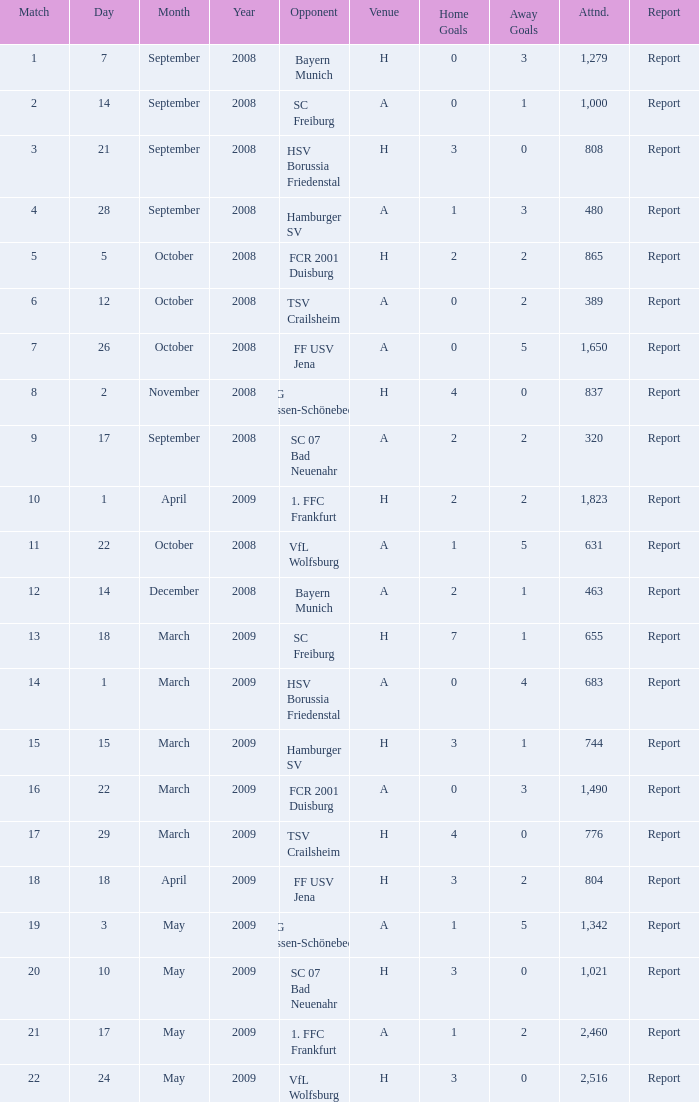What is the match number that had a result of 0:5 (0:3)? 1.0. I'm looking to parse the entire table for insights. Could you assist me with that? {'header': ['Match', 'Day', 'Month', 'Year', 'Opponent', 'Venue', 'Home Goals', 'Away Goals', 'Attnd.', 'Report'], 'rows': [['1', '7', 'September', '2008', 'Bayern Munich', 'H', '0', '3', '1,279', 'Report'], ['2', '14', 'September', '2008', 'SC Freiburg', 'A', '0', '1', '1,000', 'Report'], ['3', '21', 'September', '2008', 'HSV Borussia Friedenstal', 'H', '3', '0', '808', 'Report'], ['4', '28', 'September', '2008', 'Hamburger SV', 'A', '1', '3', '480', 'Report'], ['5', '5', 'October', '2008', 'FCR 2001 Duisburg', 'H', '2', '2', '865', 'Report'], ['6', '12', 'October', '2008', 'TSV Crailsheim', 'A', '0', '2', '389', 'Report'], ['7', '26', 'October', '2008', 'FF USV Jena', 'A', '0', '5', '1,650', 'Report'], ['8', '2', 'November', '2008', 'SG Essen-Schönebeck', 'H', '4', '0', '837', 'Report'], ['9', '17', 'September', '2008', 'SC 07 Bad Neuenahr', 'A', '2', '2', '320', 'Report'], ['10', '1', 'April', '2009', '1. FFC Frankfurt', 'H', '2', '2', '1,823', 'Report'], ['11', '22', 'October', '2008', 'VfL Wolfsburg', 'A', '1', '5', '631', 'Report'], ['12', '14', 'December', '2008', 'Bayern Munich', 'A', '2', '1', '463', 'Report'], ['13', '18', 'March', '2009', 'SC Freiburg', 'H', '7', '1', '655', 'Report'], ['14', '1', 'March', '2009', 'HSV Borussia Friedenstal', 'A', '0', '4', '683', 'Report'], ['15', '15', 'March', '2009', 'Hamburger SV', 'H', '3', '1', '744', 'Report'], ['16', '22', 'March', '2009', 'FCR 2001 Duisburg', 'A', '0', '3', '1,490', 'Report'], ['17', '29', 'March', '2009', 'TSV Crailsheim', 'H', '4', '0', '776', 'Report'], ['18', '18', 'April', '2009', 'FF USV Jena', 'H', '3', '2', '804', 'Report'], ['19', '3', 'May', '2009', 'SG Essen-Schönebeck', 'A', '1', '5', '1,342', 'Report'], ['20', '10', 'May', '2009', 'SC 07 Bad Neuenahr', 'H', '3', '0', '1,021', 'Report'], ['21', '17', 'May', '2009', '1. FFC Frankfurt', 'A', '1', '2', '2,460', 'Report'], ['22', '24', 'May', '2009', 'VfL Wolfsburg', 'H', '3', '0', '2,516', 'Report']]} 